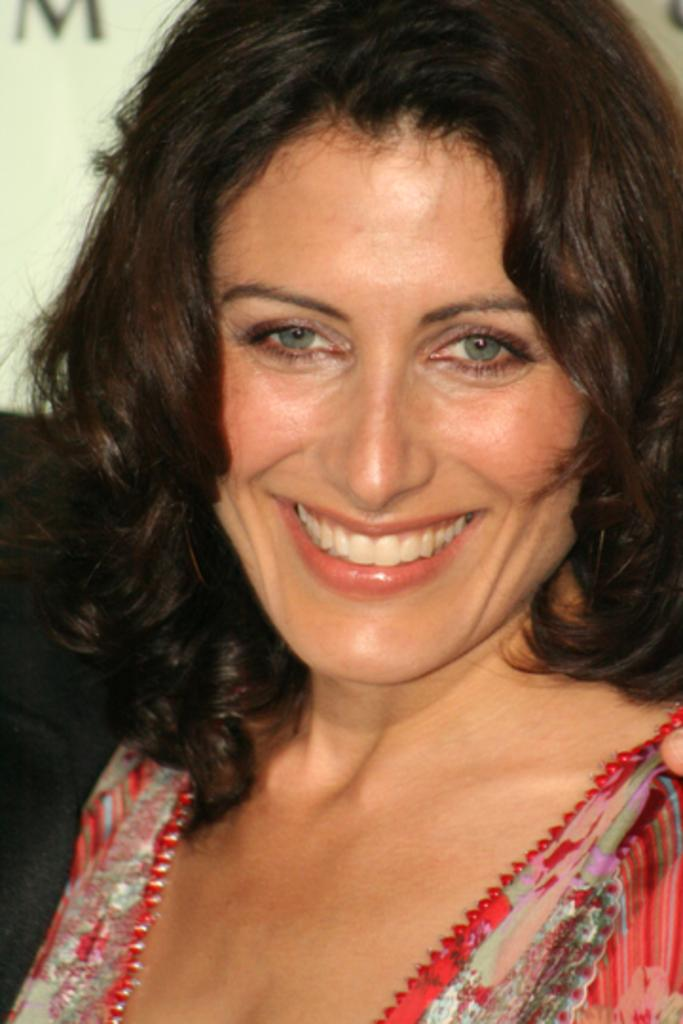What is the main subject of the image? The main subject of the image is a woman. What is the woman wearing in the image? The woman is wearing clothes in the image. What expression does the woman have in the image? The woman is smiling in the image. What type of interest does the woman have in dinosaurs in the image? There is no indication in the image that the woman has any interest in dinosaurs. What type of sink is visible in the image? There is no sink present in the image. 